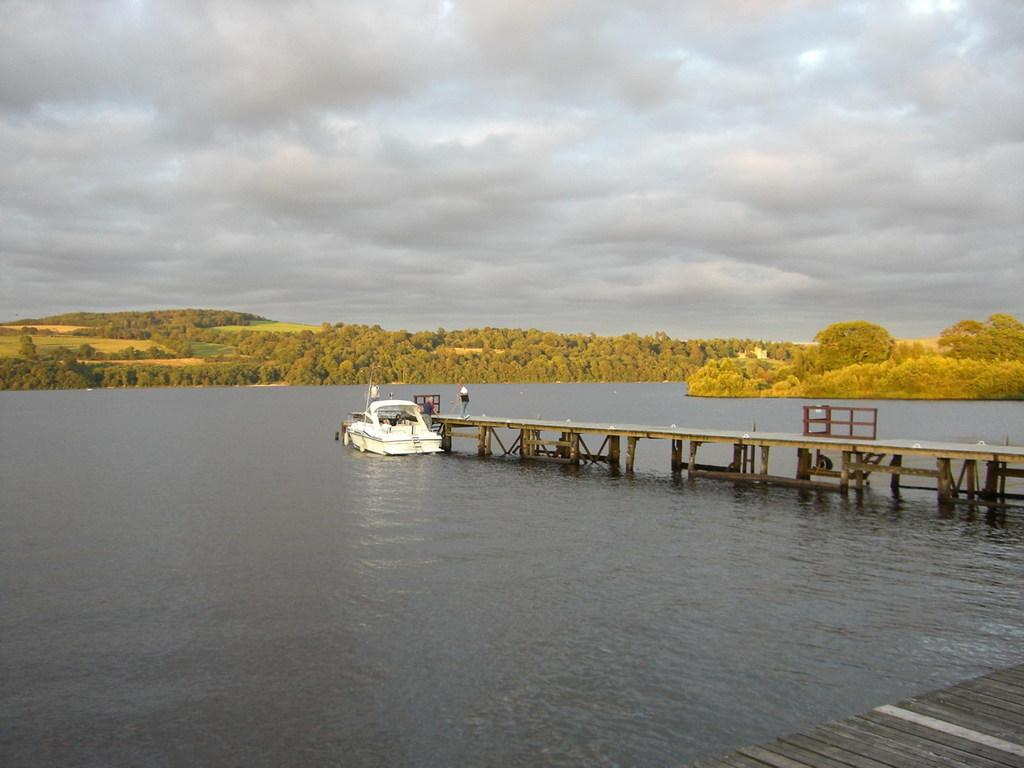What is the main subject of the image? The main subject of the image is a boat on a lake. What can be seen in the middle of the image? There is a bridge in the middle of the image. What type of vegetation is visible in the background of the image? There are trees in the background of the image. What is visible in the background of the image besides the trees? The sky is visible in the background of the image. What letters are being spelled out by the planes flying overhead in the image? There are no planes visible in the image, so no letters can be spelled out by them. 